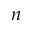Convert formula to latex. <formula><loc_0><loc_0><loc_500><loc_500>n</formula> 